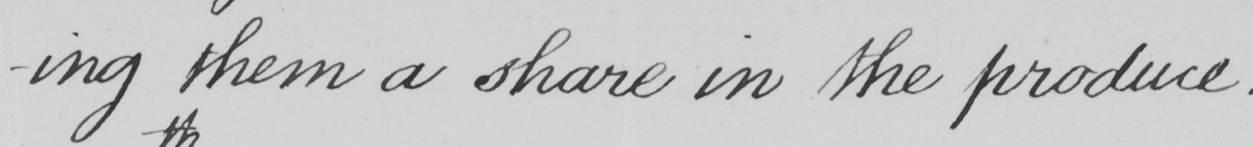What is written in this line of handwriting? -ing them a share in the produce . 